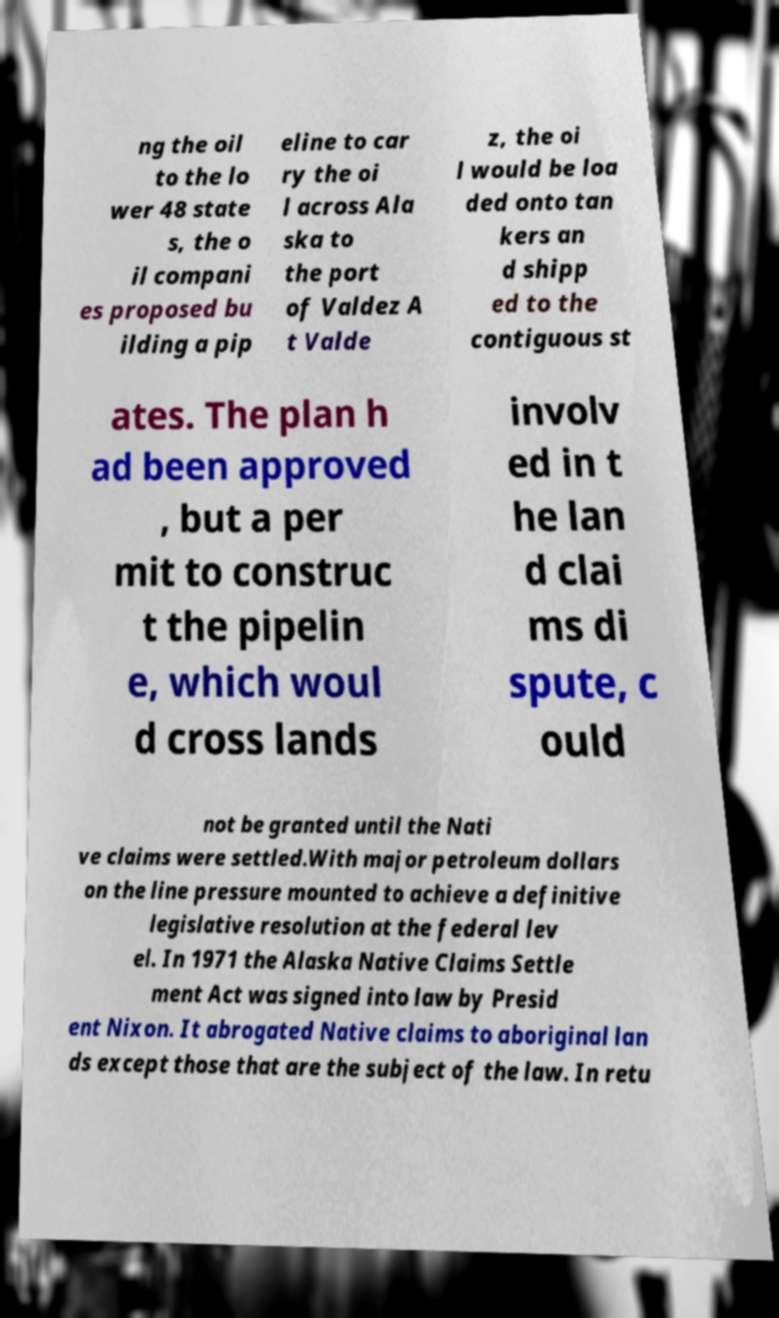What messages or text are displayed in this image? I need them in a readable, typed format. ng the oil to the lo wer 48 state s, the o il compani es proposed bu ilding a pip eline to car ry the oi l across Ala ska to the port of Valdez A t Valde z, the oi l would be loa ded onto tan kers an d shipp ed to the contiguous st ates. The plan h ad been approved , but a per mit to construc t the pipelin e, which woul d cross lands involv ed in t he lan d clai ms di spute, c ould not be granted until the Nati ve claims were settled.With major petroleum dollars on the line pressure mounted to achieve a definitive legislative resolution at the federal lev el. In 1971 the Alaska Native Claims Settle ment Act was signed into law by Presid ent Nixon. It abrogated Native claims to aboriginal lan ds except those that are the subject of the law. In retu 